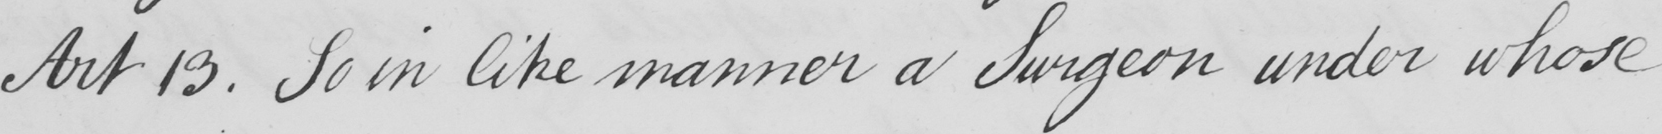Can you tell me what this handwritten text says? Art 13 . So in like manner a Surgeon under whose 